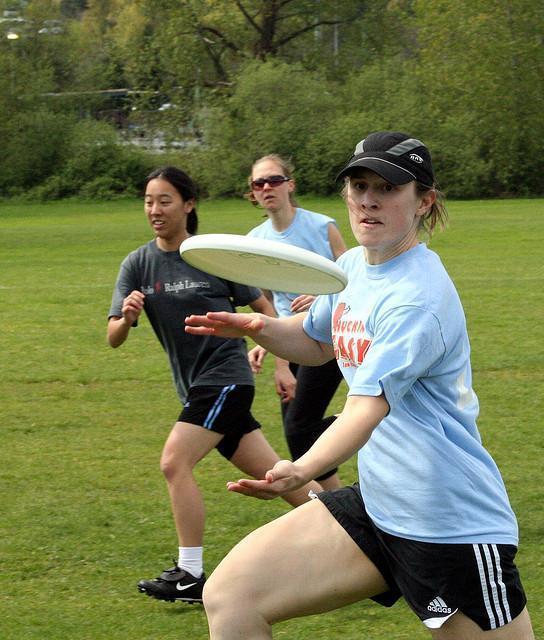How many of the women have stripes on their pants?
Give a very brief answer. 2. How many women are there?
Give a very brief answer. 3. How many people are in the picture?
Give a very brief answer. 3. 